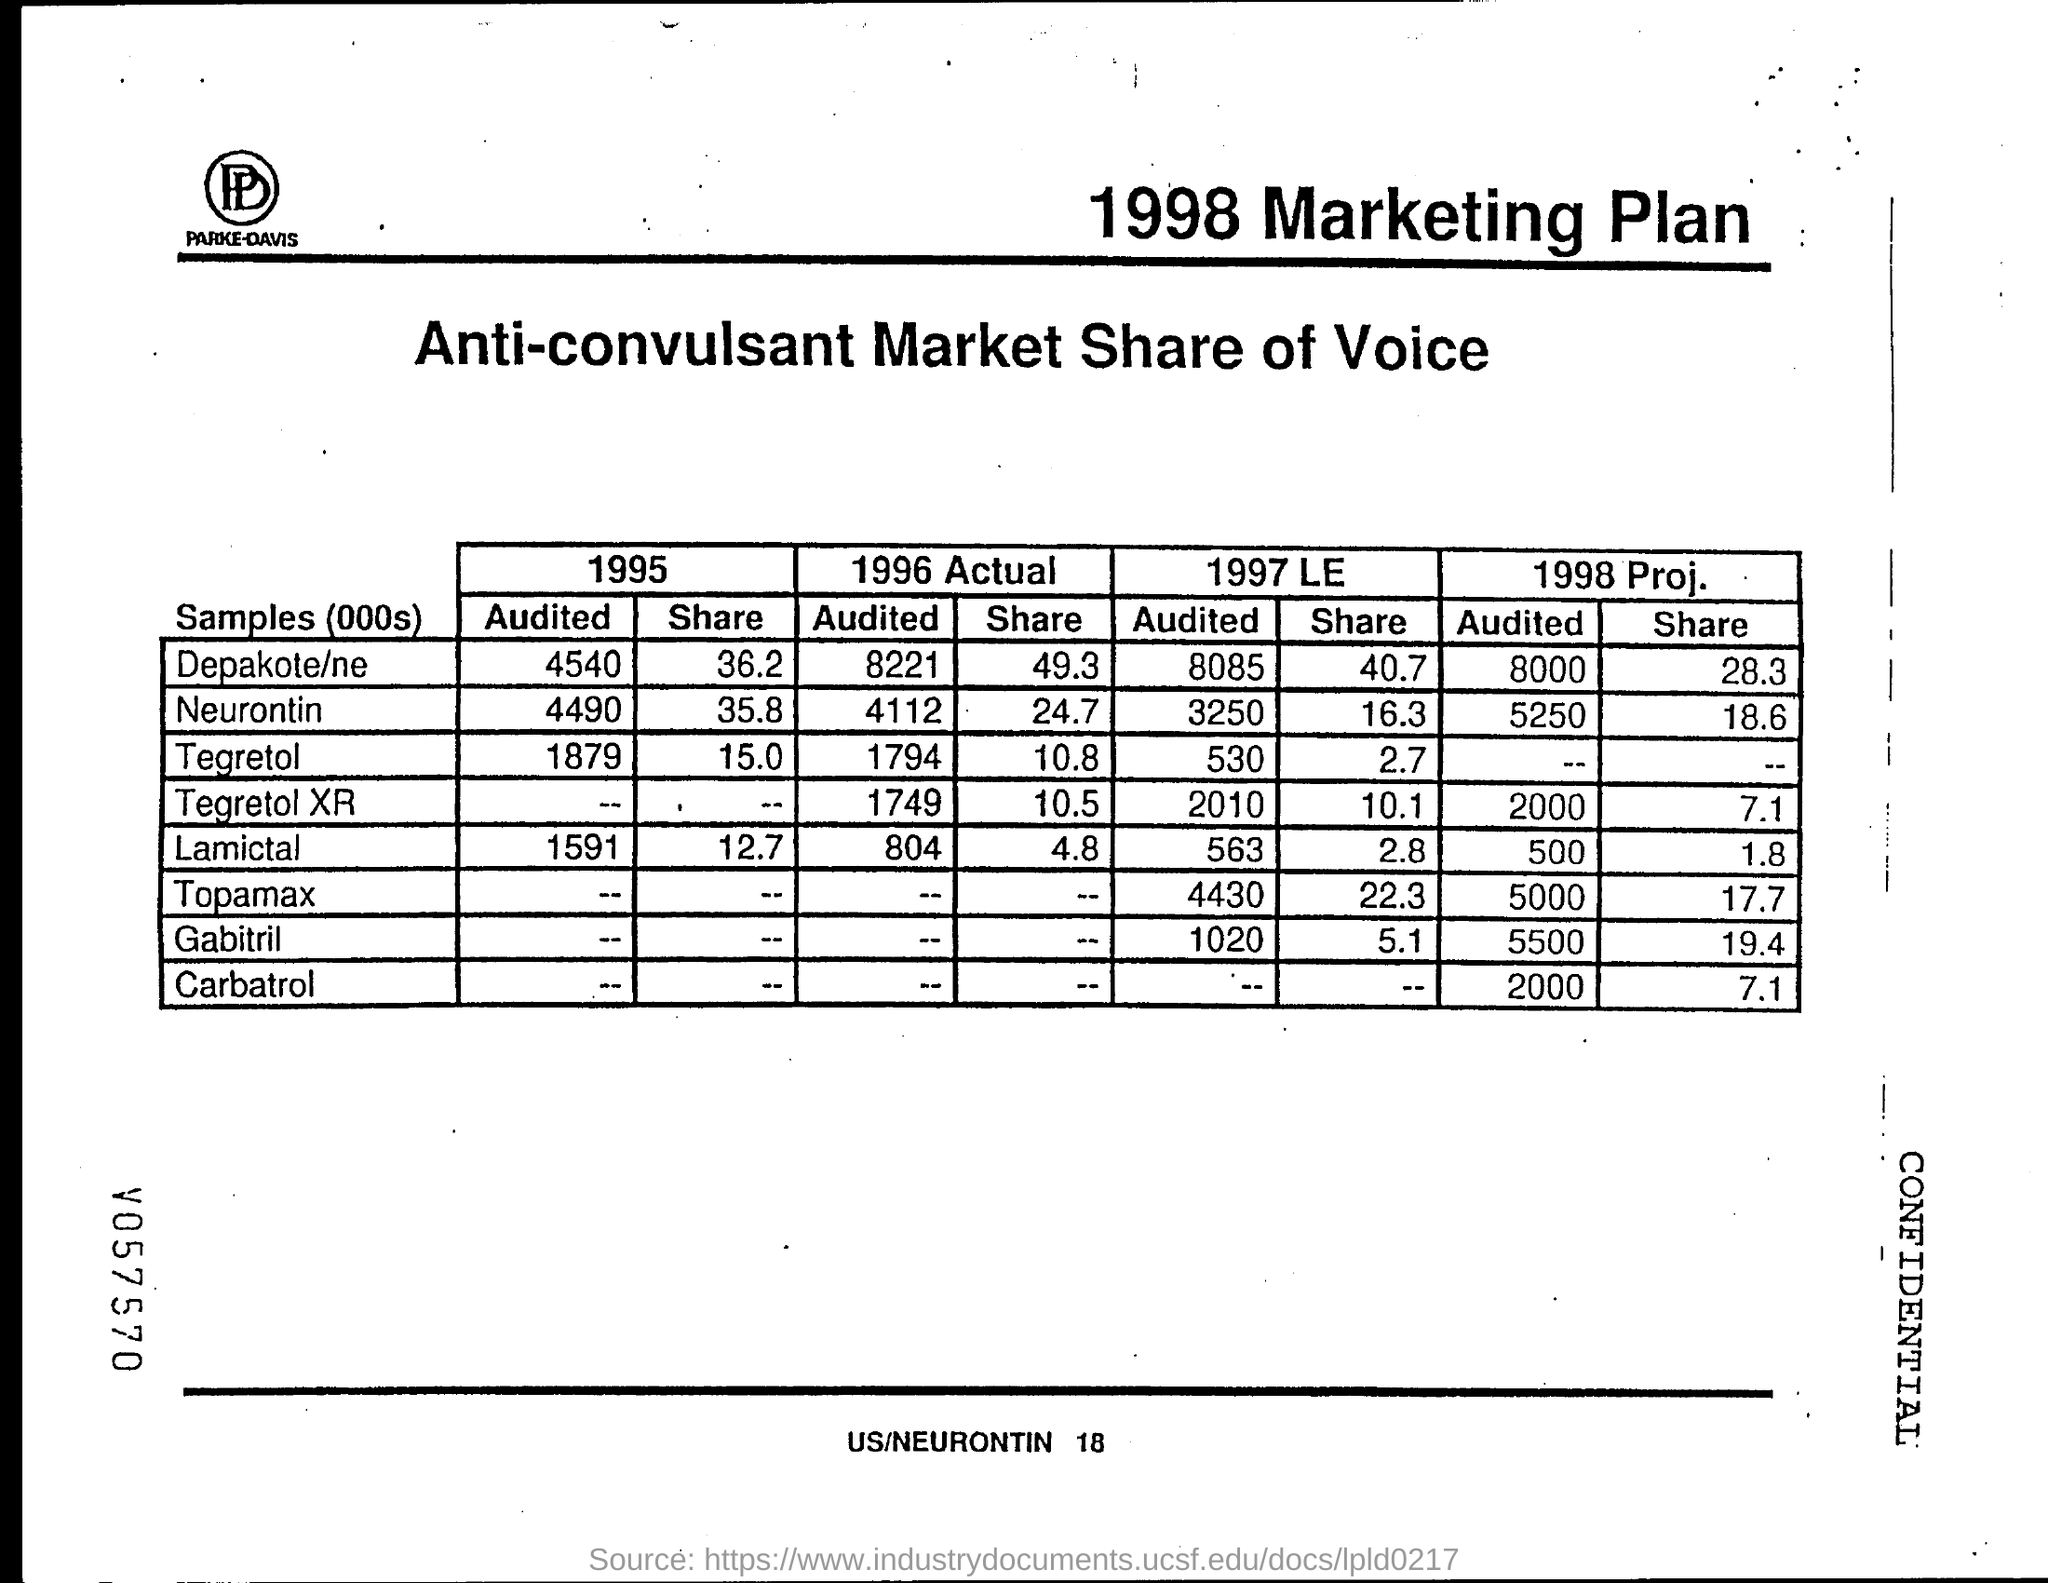Identify some key points in this picture. The Tegretol shared value for 1995 was 15. The Depakote/ne share value for 1995 was 36.2%. What is the value for Depakote/ne in 1995, specifically the audited value which was 4540? The Tegretol "audited" value for the year 1995 is 1879. It is the Neurontin value for 1996, which was audited and the actual figure is 4112. 